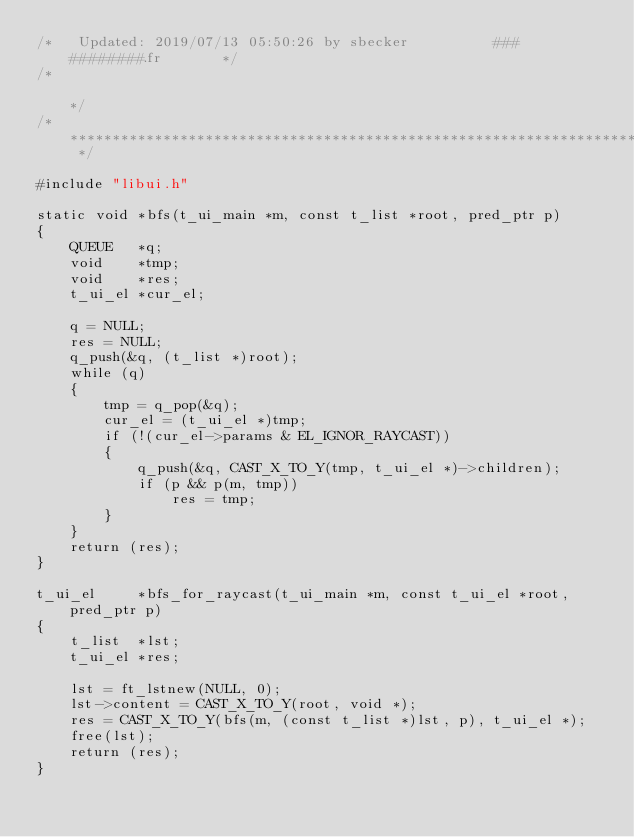<code> <loc_0><loc_0><loc_500><loc_500><_C_>/*   Updated: 2019/07/13 05:50:26 by sbecker          ###   ########.fr       */
/*                                                                            */
/* ************************************************************************** */

#include "libui.h"

static void	*bfs(t_ui_main *m, const t_list *root, pred_ptr p)
{
	QUEUE   *q;
	void    *tmp;
	void    *res;
	t_ui_el *cur_el;

	q = NULL;
	res = NULL;
	q_push(&q, (t_list *)root);
	while (q)
	{
		tmp = q_pop(&q);
		cur_el = (t_ui_el *)tmp;
		if (!(cur_el->params & EL_IGNOR_RAYCAST))
		{
			q_push(&q, CAST_X_TO_Y(tmp, t_ui_el *)->children);
			if (p && p(m, tmp))
				res = tmp;
		}
	}
	return (res);
}

t_ui_el		*bfs_for_raycast(t_ui_main *m, const t_ui_el *root, pred_ptr p)
{
	t_list  *lst;
	t_ui_el *res;

	lst = ft_lstnew(NULL, 0);
	lst->content = CAST_X_TO_Y(root, void *);
	res = CAST_X_TO_Y(bfs(m, (const t_list *)lst, p), t_ui_el *);
	free(lst);
	return (res);
}
</code> 